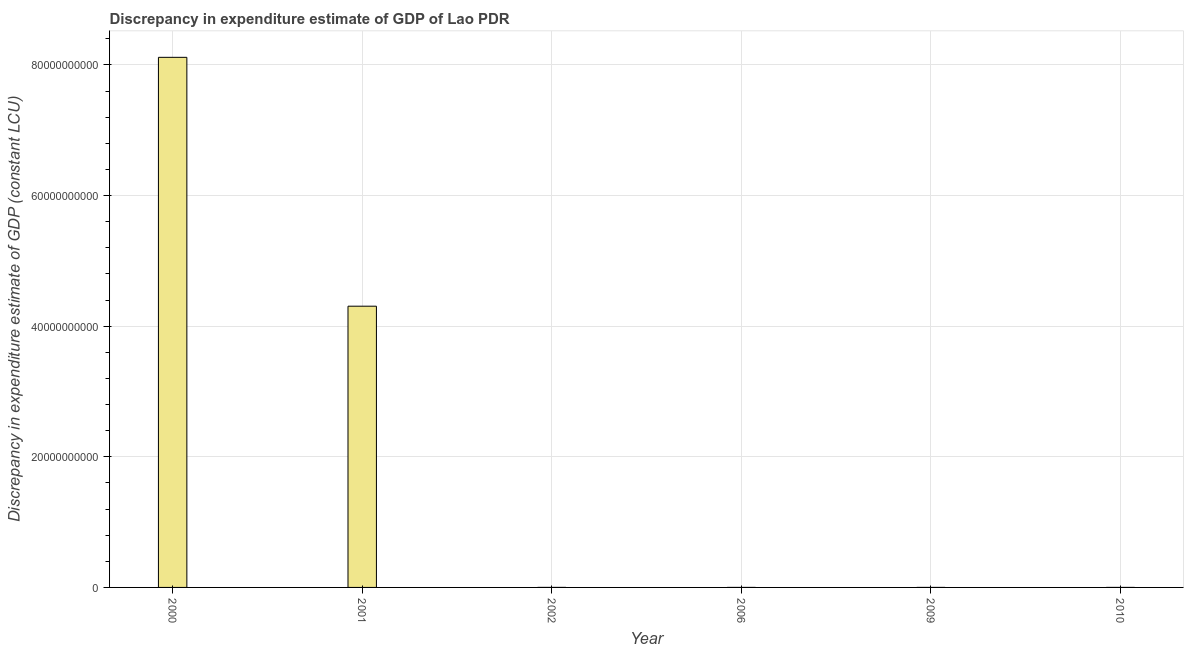What is the title of the graph?
Make the answer very short. Discrepancy in expenditure estimate of GDP of Lao PDR. What is the label or title of the X-axis?
Your answer should be very brief. Year. What is the label or title of the Y-axis?
Offer a very short reply. Discrepancy in expenditure estimate of GDP (constant LCU). What is the discrepancy in expenditure estimate of gdp in 2000?
Make the answer very short. 8.12e+1. Across all years, what is the maximum discrepancy in expenditure estimate of gdp?
Ensure brevity in your answer.  8.12e+1. Across all years, what is the minimum discrepancy in expenditure estimate of gdp?
Give a very brief answer. 0. What is the sum of the discrepancy in expenditure estimate of gdp?
Ensure brevity in your answer.  1.24e+11. What is the difference between the discrepancy in expenditure estimate of gdp in 2000 and 2001?
Give a very brief answer. 3.81e+1. What is the average discrepancy in expenditure estimate of gdp per year?
Provide a succinct answer. 2.07e+1. What is the median discrepancy in expenditure estimate of gdp?
Make the answer very short. 3.71e+05. What is the ratio of the discrepancy in expenditure estimate of gdp in 2001 to that in 2002?
Your answer should be compact. 5.81e+04. What is the difference between the highest and the second highest discrepancy in expenditure estimate of gdp?
Keep it short and to the point. 3.81e+1. Is the sum of the discrepancy in expenditure estimate of gdp in 2001 and 2002 greater than the maximum discrepancy in expenditure estimate of gdp across all years?
Your response must be concise. No. What is the difference between the highest and the lowest discrepancy in expenditure estimate of gdp?
Offer a terse response. 8.12e+1. How many bars are there?
Make the answer very short. 4. Are all the bars in the graph horizontal?
Your response must be concise. No. How many years are there in the graph?
Make the answer very short. 6. What is the difference between two consecutive major ticks on the Y-axis?
Ensure brevity in your answer.  2.00e+1. Are the values on the major ticks of Y-axis written in scientific E-notation?
Make the answer very short. No. What is the Discrepancy in expenditure estimate of GDP (constant LCU) of 2000?
Your answer should be very brief. 8.12e+1. What is the Discrepancy in expenditure estimate of GDP (constant LCU) in 2001?
Offer a very short reply. 4.31e+1. What is the Discrepancy in expenditure estimate of GDP (constant LCU) of 2002?
Offer a terse response. 7.42e+05. What is the Discrepancy in expenditure estimate of GDP (constant LCU) of 2009?
Offer a terse response. 0. What is the Discrepancy in expenditure estimate of GDP (constant LCU) in 2010?
Provide a succinct answer. 100. What is the difference between the Discrepancy in expenditure estimate of GDP (constant LCU) in 2000 and 2001?
Your answer should be very brief. 3.81e+1. What is the difference between the Discrepancy in expenditure estimate of GDP (constant LCU) in 2000 and 2002?
Your answer should be compact. 8.12e+1. What is the difference between the Discrepancy in expenditure estimate of GDP (constant LCU) in 2000 and 2010?
Give a very brief answer. 8.12e+1. What is the difference between the Discrepancy in expenditure estimate of GDP (constant LCU) in 2001 and 2002?
Your answer should be compact. 4.31e+1. What is the difference between the Discrepancy in expenditure estimate of GDP (constant LCU) in 2001 and 2010?
Offer a very short reply. 4.31e+1. What is the difference between the Discrepancy in expenditure estimate of GDP (constant LCU) in 2002 and 2010?
Give a very brief answer. 7.42e+05. What is the ratio of the Discrepancy in expenditure estimate of GDP (constant LCU) in 2000 to that in 2001?
Keep it short and to the point. 1.89. What is the ratio of the Discrepancy in expenditure estimate of GDP (constant LCU) in 2000 to that in 2002?
Provide a short and direct response. 1.09e+05. What is the ratio of the Discrepancy in expenditure estimate of GDP (constant LCU) in 2000 to that in 2010?
Ensure brevity in your answer.  8.12e+08. What is the ratio of the Discrepancy in expenditure estimate of GDP (constant LCU) in 2001 to that in 2002?
Offer a very short reply. 5.81e+04. What is the ratio of the Discrepancy in expenditure estimate of GDP (constant LCU) in 2001 to that in 2010?
Give a very brief answer. 4.31e+08. What is the ratio of the Discrepancy in expenditure estimate of GDP (constant LCU) in 2002 to that in 2010?
Ensure brevity in your answer.  7418. 